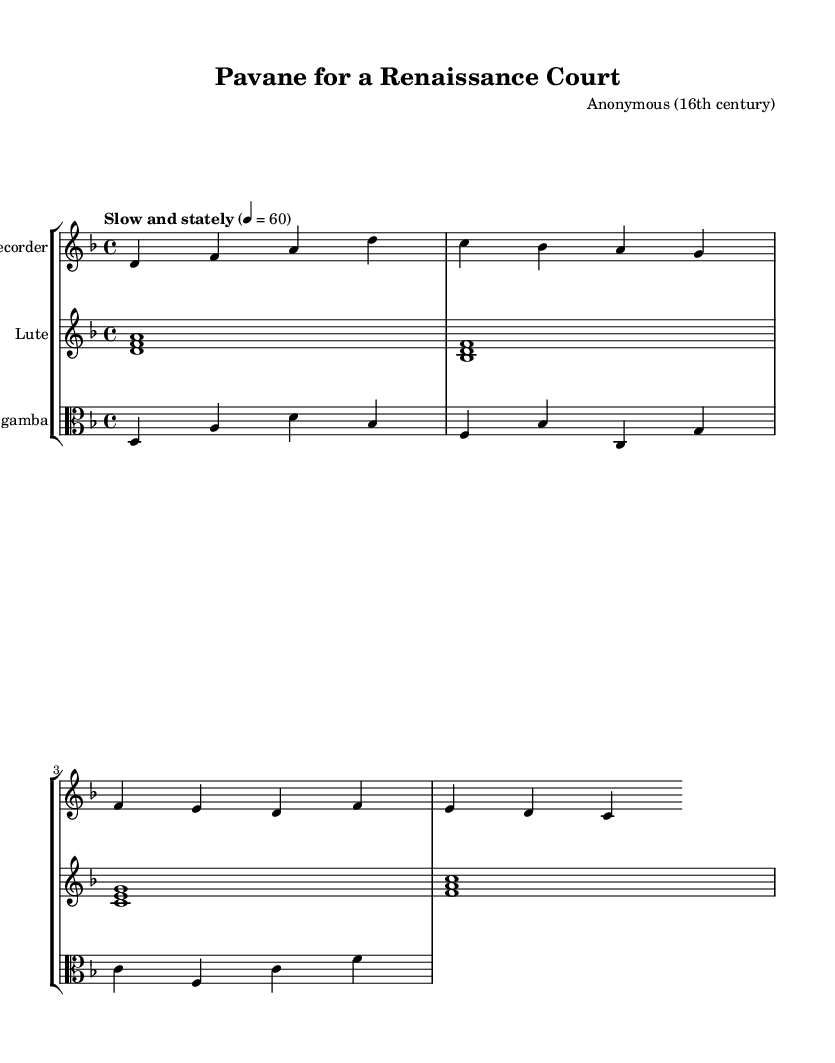What is the key signature of this music? The key signature shows two flats (B flat and E flat), which indicates that the music is in D minor.
Answer: D minor What is the time signature of this piece? The time signature indicates that there are four beats in each measure, shown as 4/4.
Answer: 4/4 What is the tempo marking of this piece? The tempo marking is specified as "Slow and stately" with a metronome marking of 60 beats per minute, suggesting a relaxed pace.
Answer: Slow and stately What type of ensemble is indicated in the score? The score contains three different instruments: a recorder, a lute, and a viola da gamba, indicating a small Renaissance ensemble.
Answer: Trio How many measures are present in the melody for each instrument? Each instrument's melody consists of four measures, as the lines are organized into four distinct groups of notes.
Answer: Four measures Which instrument plays the melody for the longest duration? The lute plays sustained chords throughout the piece, giving it a longer duration than the other parts, which have shorter note values.
Answer: Lute What does the structure of the melody suggest about this piece? The melody exhibits a repetitive and structured pattern often found in courtly dances, typical of the Pavane style from the Renaissance period.
Answer: Pavane style 